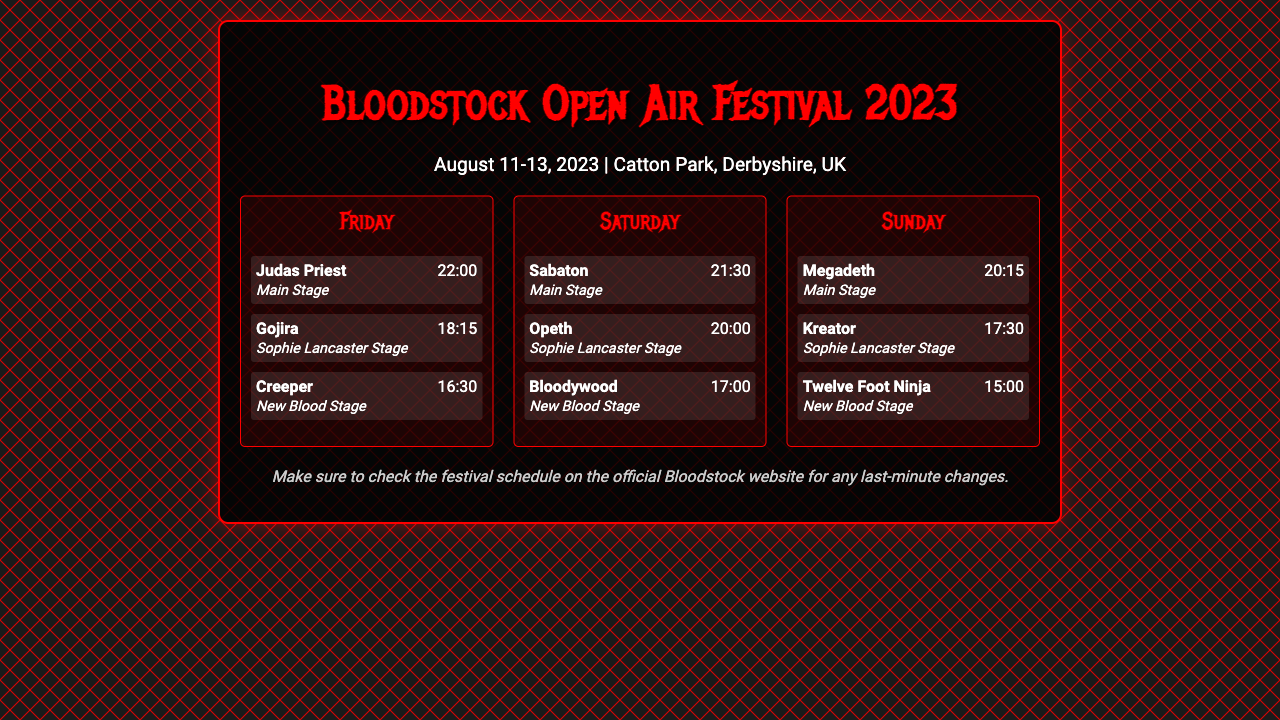What is the location of the festival? The festival is taking place at Catton Park, Derbyshire, UK.
Answer: Catton Park, Derbyshire, UK What band is performing last on Friday? The last band performing on Friday is Judas Priest at 22:00.
Answer: Judas Priest What stage is Megadeth playing on? Megadeth is scheduled to perform on the Main Stage.
Answer: Main Stage How many bands are listed for Saturday? There are three bands listed for Saturday in the document.
Answer: 3 What time does Sabaton perform? Sabaton is scheduled to perform at 21:30 on Saturday.
Answer: 21:30 Which band performs at 15:00 on Sunday? The band scheduled to perform at 15:00 on Sunday is Twelve Foot Ninja.
Answer: Twelve Foot Ninja What is the earliest set time on Friday? The earliest set time on Friday is for Creeper at 16:30.
Answer: 16:30 How should festival-goers check for changes? Festival-goers are advised to check the official Bloodstock website for updates.
Answer: Official Bloodstock website 